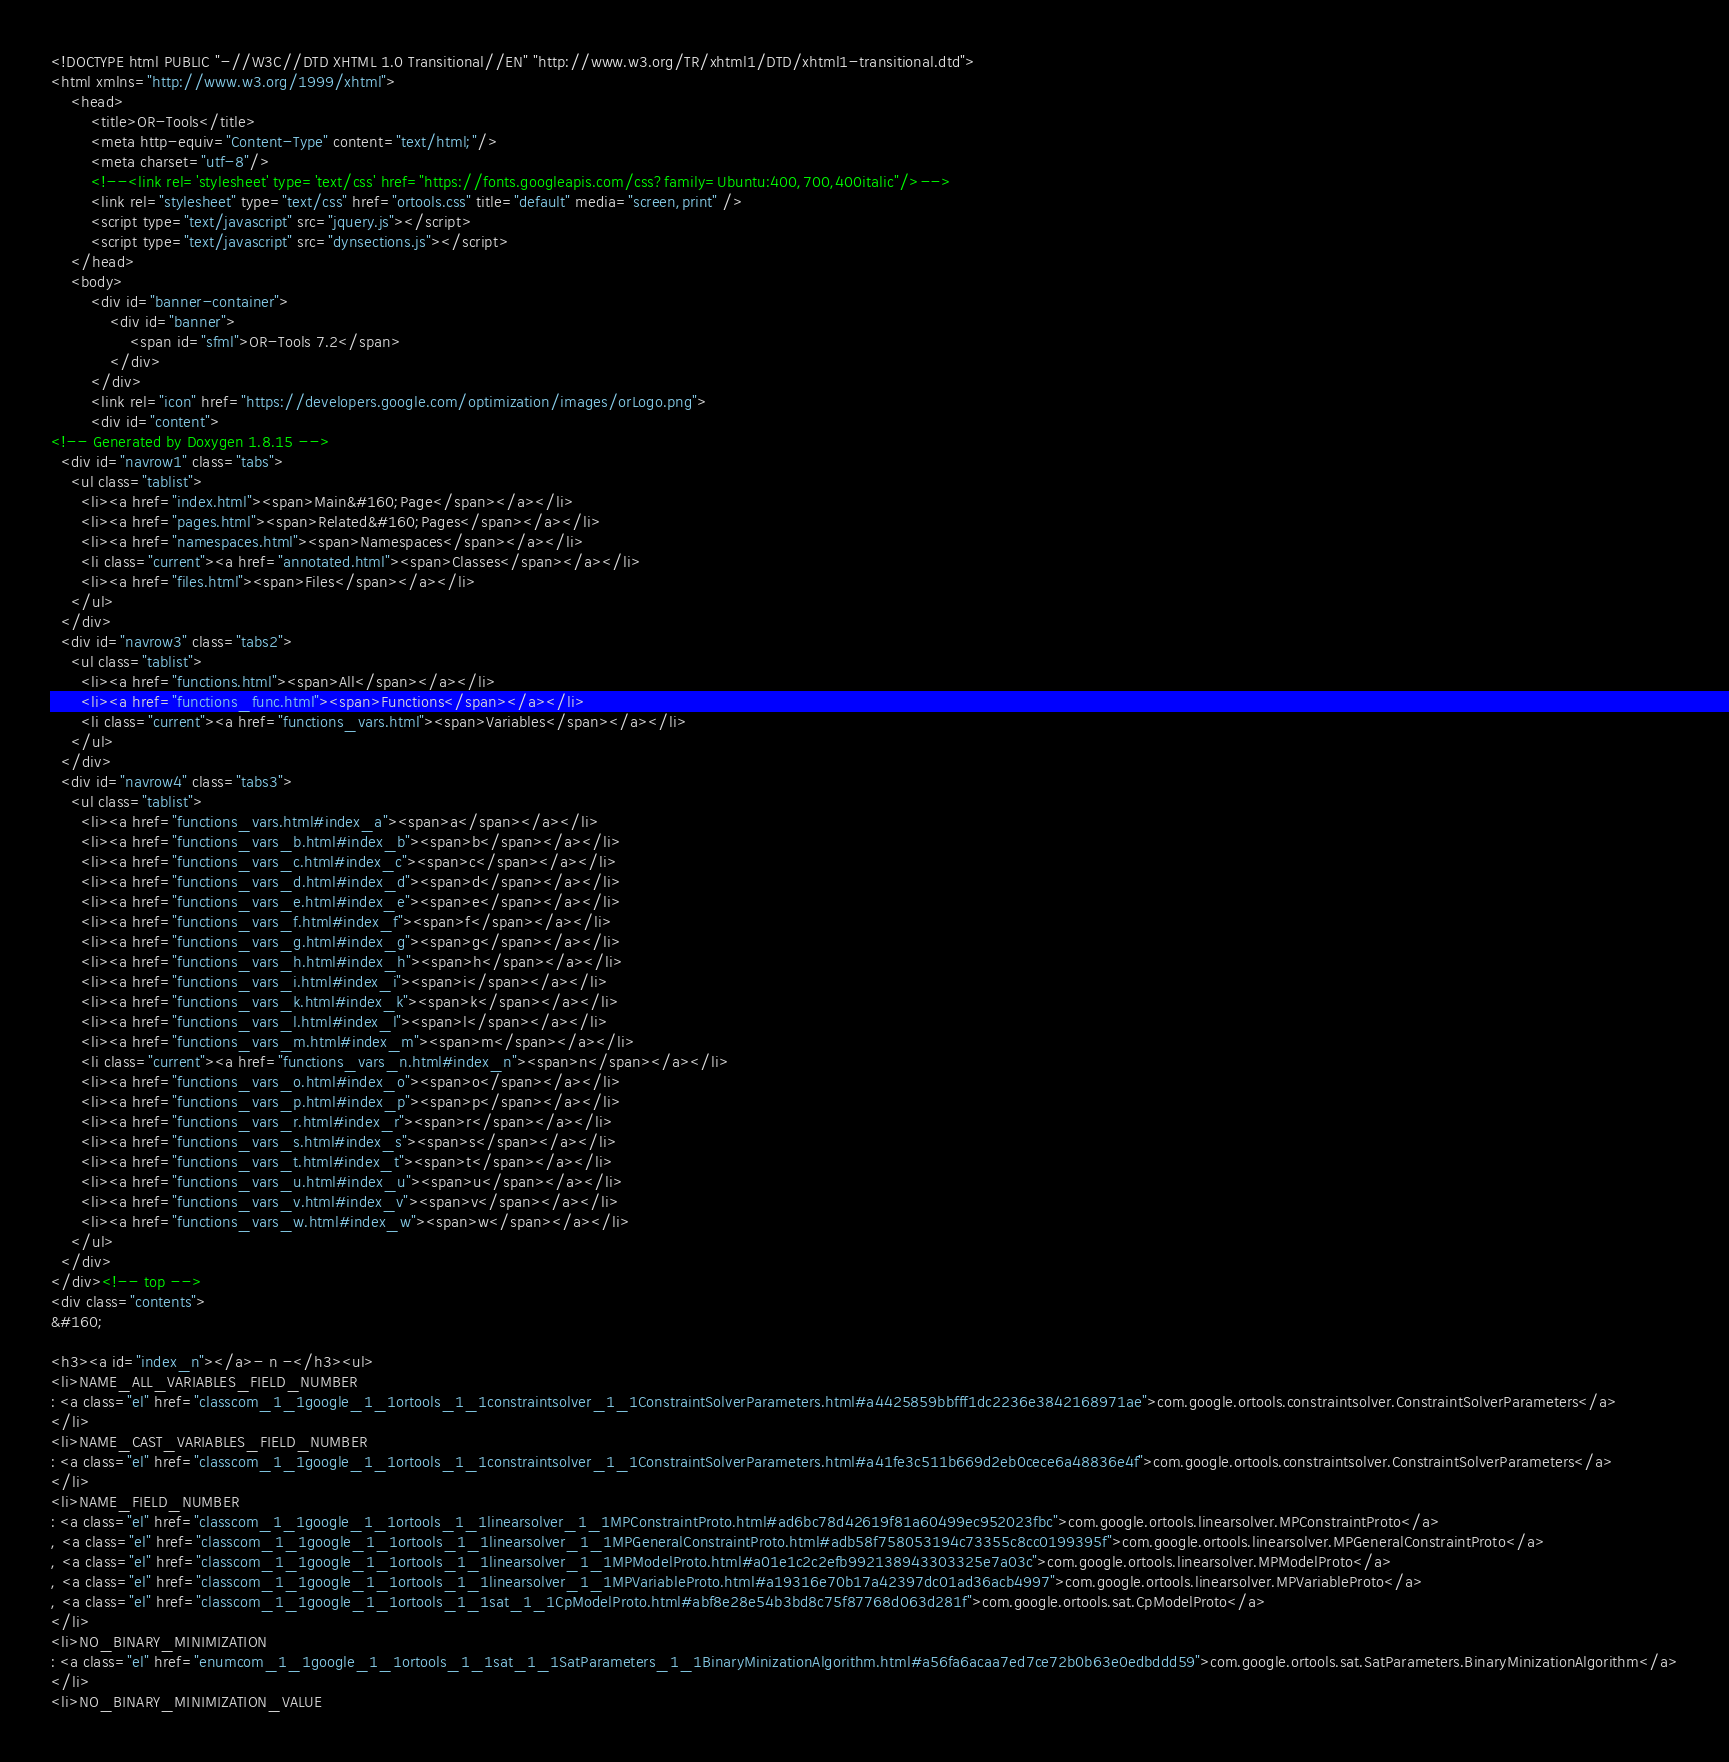Convert code to text. <code><loc_0><loc_0><loc_500><loc_500><_HTML_><!DOCTYPE html PUBLIC "-//W3C//DTD XHTML 1.0 Transitional//EN" "http://www.w3.org/TR/xhtml1/DTD/xhtml1-transitional.dtd">
<html xmlns="http://www.w3.org/1999/xhtml">
    <head>
        <title>OR-Tools</title>
        <meta http-equiv="Content-Type" content="text/html;"/>
        <meta charset="utf-8"/>
        <!--<link rel='stylesheet' type='text/css' href="https://fonts.googleapis.com/css?family=Ubuntu:400,700,400italic"/>-->
        <link rel="stylesheet" type="text/css" href="ortools.css" title="default" media="screen,print" />
        <script type="text/javascript" src="jquery.js"></script>
        <script type="text/javascript" src="dynsections.js"></script>
    </head>
    <body>
        <div id="banner-container">
            <div id="banner">
                <span id="sfml">OR-Tools 7.2</span>
            </div>
        </div>
        <link rel="icon" href="https://developers.google.com/optimization/images/orLogo.png">
        <div id="content">
<!-- Generated by Doxygen 1.8.15 -->
  <div id="navrow1" class="tabs">
    <ul class="tablist">
      <li><a href="index.html"><span>Main&#160;Page</span></a></li>
      <li><a href="pages.html"><span>Related&#160;Pages</span></a></li>
      <li><a href="namespaces.html"><span>Namespaces</span></a></li>
      <li class="current"><a href="annotated.html"><span>Classes</span></a></li>
      <li><a href="files.html"><span>Files</span></a></li>
    </ul>
  </div>
  <div id="navrow3" class="tabs2">
    <ul class="tablist">
      <li><a href="functions.html"><span>All</span></a></li>
      <li><a href="functions_func.html"><span>Functions</span></a></li>
      <li class="current"><a href="functions_vars.html"><span>Variables</span></a></li>
    </ul>
  </div>
  <div id="navrow4" class="tabs3">
    <ul class="tablist">
      <li><a href="functions_vars.html#index_a"><span>a</span></a></li>
      <li><a href="functions_vars_b.html#index_b"><span>b</span></a></li>
      <li><a href="functions_vars_c.html#index_c"><span>c</span></a></li>
      <li><a href="functions_vars_d.html#index_d"><span>d</span></a></li>
      <li><a href="functions_vars_e.html#index_e"><span>e</span></a></li>
      <li><a href="functions_vars_f.html#index_f"><span>f</span></a></li>
      <li><a href="functions_vars_g.html#index_g"><span>g</span></a></li>
      <li><a href="functions_vars_h.html#index_h"><span>h</span></a></li>
      <li><a href="functions_vars_i.html#index_i"><span>i</span></a></li>
      <li><a href="functions_vars_k.html#index_k"><span>k</span></a></li>
      <li><a href="functions_vars_l.html#index_l"><span>l</span></a></li>
      <li><a href="functions_vars_m.html#index_m"><span>m</span></a></li>
      <li class="current"><a href="functions_vars_n.html#index_n"><span>n</span></a></li>
      <li><a href="functions_vars_o.html#index_o"><span>o</span></a></li>
      <li><a href="functions_vars_p.html#index_p"><span>p</span></a></li>
      <li><a href="functions_vars_r.html#index_r"><span>r</span></a></li>
      <li><a href="functions_vars_s.html#index_s"><span>s</span></a></li>
      <li><a href="functions_vars_t.html#index_t"><span>t</span></a></li>
      <li><a href="functions_vars_u.html#index_u"><span>u</span></a></li>
      <li><a href="functions_vars_v.html#index_v"><span>v</span></a></li>
      <li><a href="functions_vars_w.html#index_w"><span>w</span></a></li>
    </ul>
  </div>
</div><!-- top -->
<div class="contents">
&#160;

<h3><a id="index_n"></a>- n -</h3><ul>
<li>NAME_ALL_VARIABLES_FIELD_NUMBER
: <a class="el" href="classcom_1_1google_1_1ortools_1_1constraintsolver_1_1ConstraintSolverParameters.html#a4425859bbfff1dc2236e3842168971ae">com.google.ortools.constraintsolver.ConstraintSolverParameters</a>
</li>
<li>NAME_CAST_VARIABLES_FIELD_NUMBER
: <a class="el" href="classcom_1_1google_1_1ortools_1_1constraintsolver_1_1ConstraintSolverParameters.html#a41fe3c511b669d2eb0cece6a48836e4f">com.google.ortools.constraintsolver.ConstraintSolverParameters</a>
</li>
<li>NAME_FIELD_NUMBER
: <a class="el" href="classcom_1_1google_1_1ortools_1_1linearsolver_1_1MPConstraintProto.html#ad6bc78d42619f81a60499ec952023fbc">com.google.ortools.linearsolver.MPConstraintProto</a>
, <a class="el" href="classcom_1_1google_1_1ortools_1_1linearsolver_1_1MPGeneralConstraintProto.html#adb58f758053194c73355c8cc0199395f">com.google.ortools.linearsolver.MPGeneralConstraintProto</a>
, <a class="el" href="classcom_1_1google_1_1ortools_1_1linearsolver_1_1MPModelProto.html#a01e1c2c2efb992138943303325e7a03c">com.google.ortools.linearsolver.MPModelProto</a>
, <a class="el" href="classcom_1_1google_1_1ortools_1_1linearsolver_1_1MPVariableProto.html#a19316e70b17a42397dc01ad36acb4997">com.google.ortools.linearsolver.MPVariableProto</a>
, <a class="el" href="classcom_1_1google_1_1ortools_1_1sat_1_1CpModelProto.html#abf8e28e54b3bd8c75f87768d063d281f">com.google.ortools.sat.CpModelProto</a>
</li>
<li>NO_BINARY_MINIMIZATION
: <a class="el" href="enumcom_1_1google_1_1ortools_1_1sat_1_1SatParameters_1_1BinaryMinizationAlgorithm.html#a56fa6acaa7ed7ce72b0b63e0edbddd59">com.google.ortools.sat.SatParameters.BinaryMinizationAlgorithm</a>
</li>
<li>NO_BINARY_MINIMIZATION_VALUE</code> 